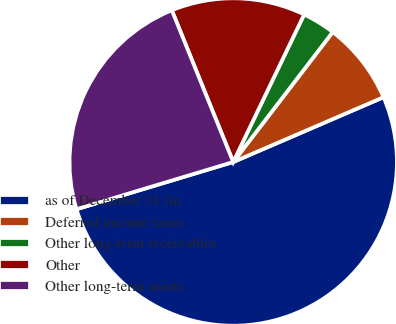<chart> <loc_0><loc_0><loc_500><loc_500><pie_chart><fcel>as of December 31 (in<fcel>Deferred income taxes<fcel>Other long-term receivables<fcel>Other<fcel>Other long-term assets<nl><fcel>51.82%<fcel>8.12%<fcel>3.27%<fcel>13.25%<fcel>23.54%<nl></chart> 